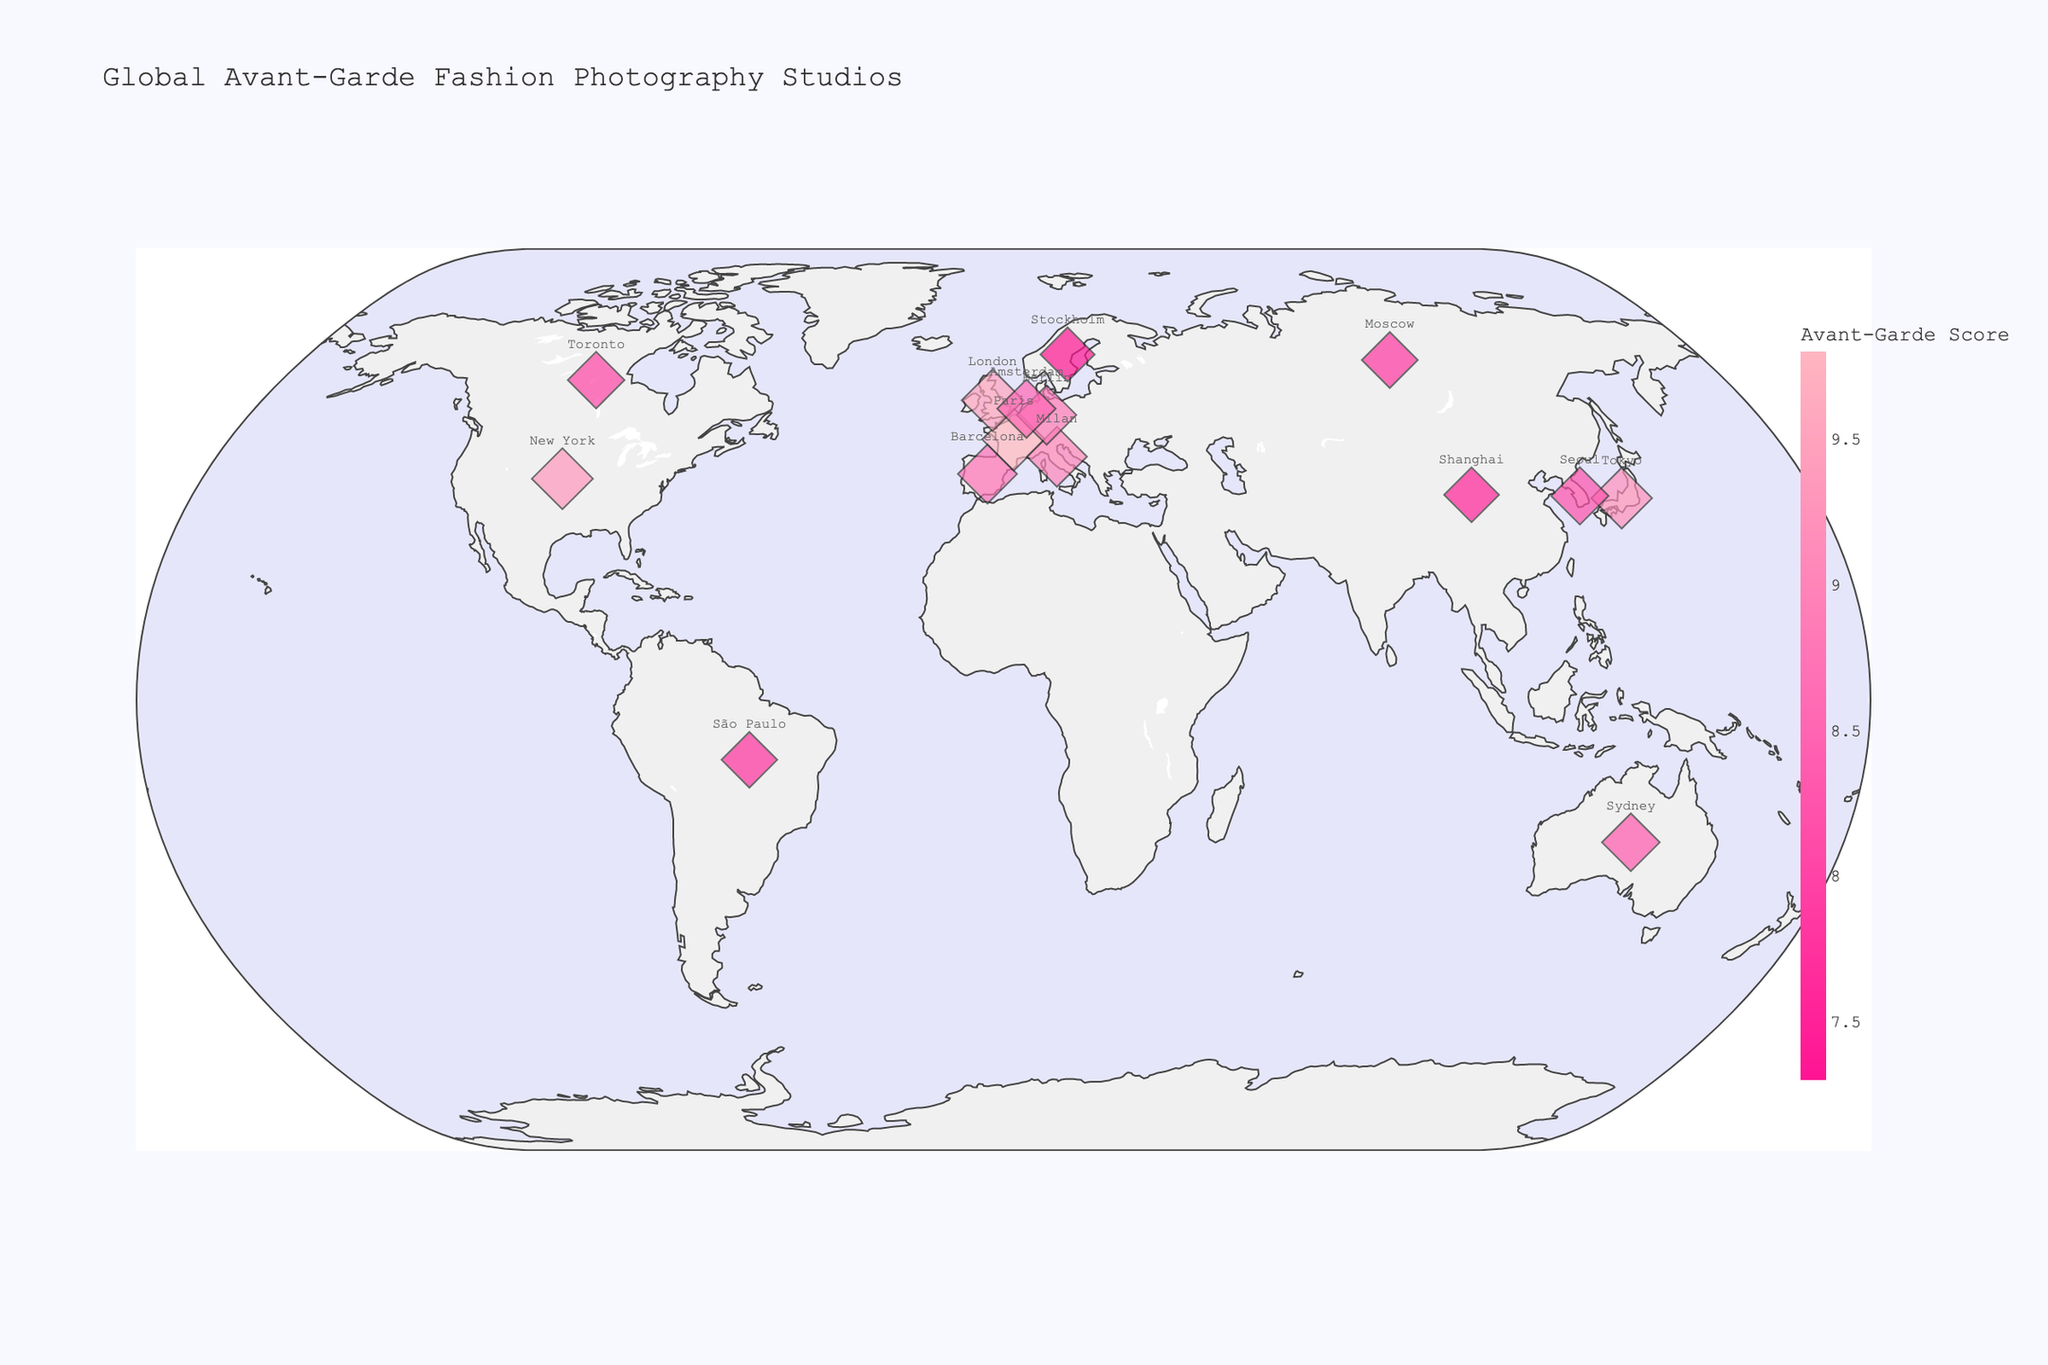What is the title of the figure? The title is typically found at the top of the figure and usually summarizes what the visualization is about.
Answer: Global Avant-Garde Fashion Photography Studios Which city has the studio with the highest Avant-Garde Specialty Score? The highest score's location is often represented by the largest and darkest marker on the plot. Check markers and hover over them to see the score and studio name.
Answer: Paris How many studios have an Avant-Garde Specialty Score greater than 9.0? Examine the markers and hover over them or refer to the color legend for the scores. Count the studios with scores above 9.0.
Answer: 4 Which country has the most studios listed on the plot? Look at the number of markers in each country. The country with multiple markers would be the answer.
Answer: United States Compare the Avant-Garde Specialty Scores between Edgelight Studios in New York and Futurismo Fotografico in Milan. Which one is higher? Find the markers for New York and Milan, hover over them to see the scores, and compare them.
Answer: New York (9.3) What is the average Avant-Garde Specialty Score for the studios located in Europe? Identify European countries (France, UK, Italy, Germany, Spain, Netherlands, Sweden, Russia), sum their scores, and divide by the number of studios.
Answer: 8.92 Are there more studios with total Avant-Garde Specialty Scores above 9.0 in Asia or Europe? Count studios in Asian countries (Japan, South Korea, China) and European countries (France, UK, Italy, Germany, Spain, Netherlands, Sweden, Russia) with scores above 9.0. Compare the counts.
Answer: Europe Which studio in Asia has the lowest Avant-Garde Specialty Score? Identify markers in Asian countries (Japan, South Korea, China) and check their scores. The lowest score corresponds to the studio you need.
Answer: Eastern Vanguard in Shanghai What is the total Avant-Garde Specialty Score for studios in North and South America? Identify studios in the Americas (United States, Canada, Brazil), sum their scores to get the total.
Answer: 25 Is the distribution of avant-garde fashion photography studios global, or are there regions with noticeably fewer studios? Examine the geographic spread of markers on the map, noting regions with many versus few markers.
Answer: More studios in Europe and North America, fewer in Africa and most of Asia 